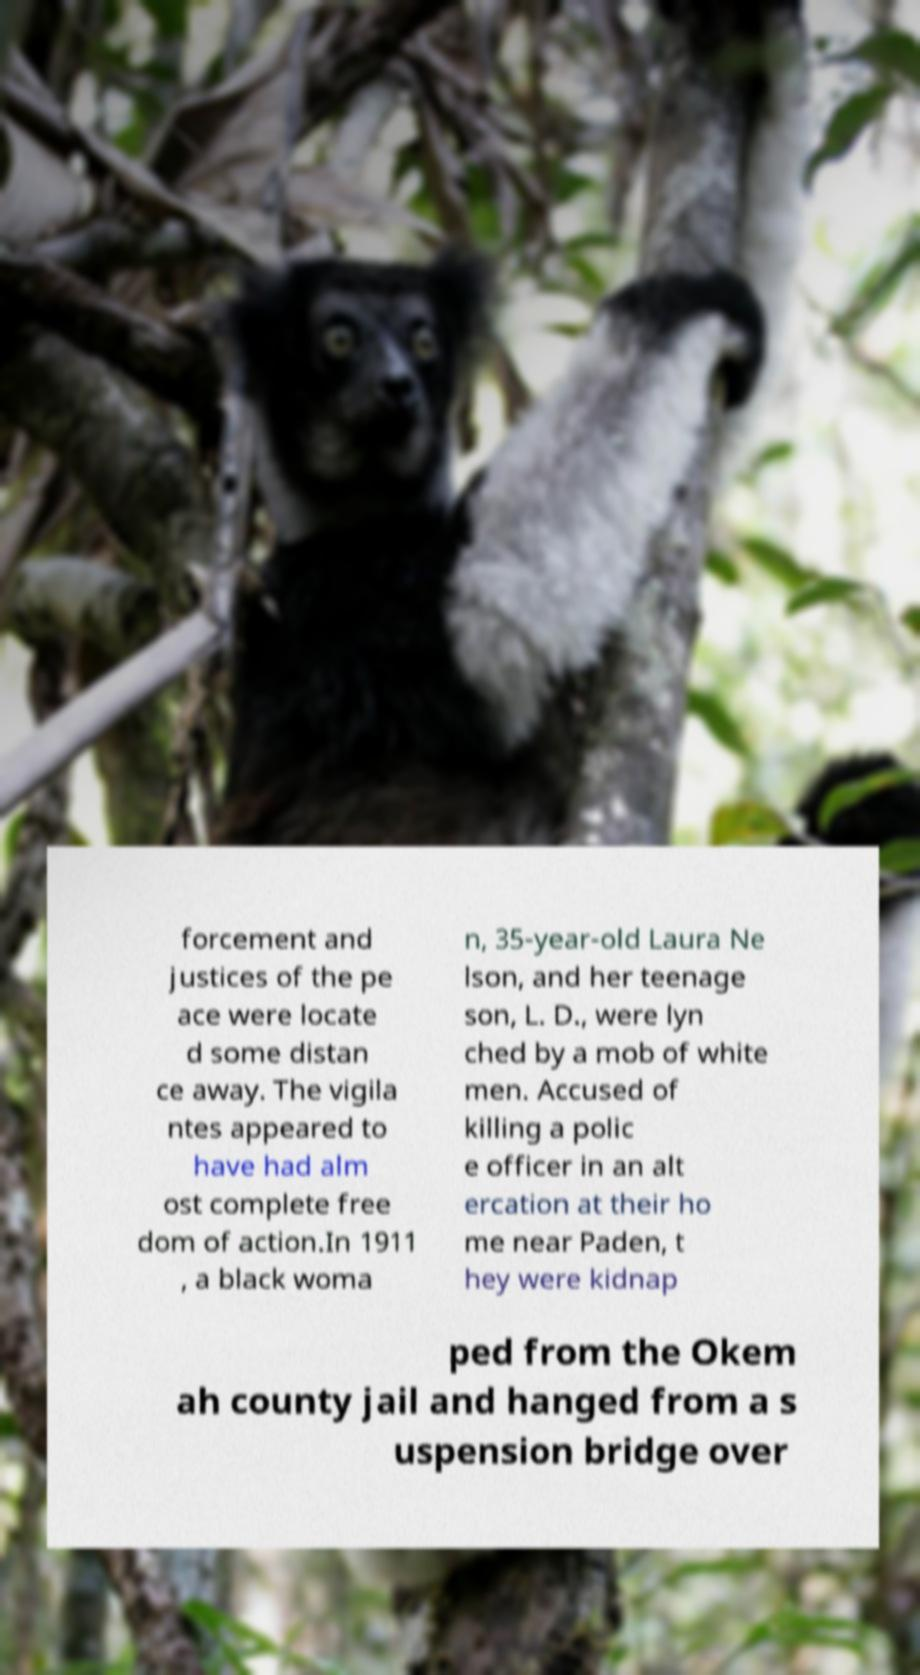What messages or text are displayed in this image? I need them in a readable, typed format. forcement and justices of the pe ace were locate d some distan ce away. The vigila ntes appeared to have had alm ost complete free dom of action.In 1911 , a black woma n, 35-year-old Laura Ne lson, and her teenage son, L. D., were lyn ched by a mob of white men. Accused of killing a polic e officer in an alt ercation at their ho me near Paden, t hey were kidnap ped from the Okem ah county jail and hanged from a s uspension bridge over 